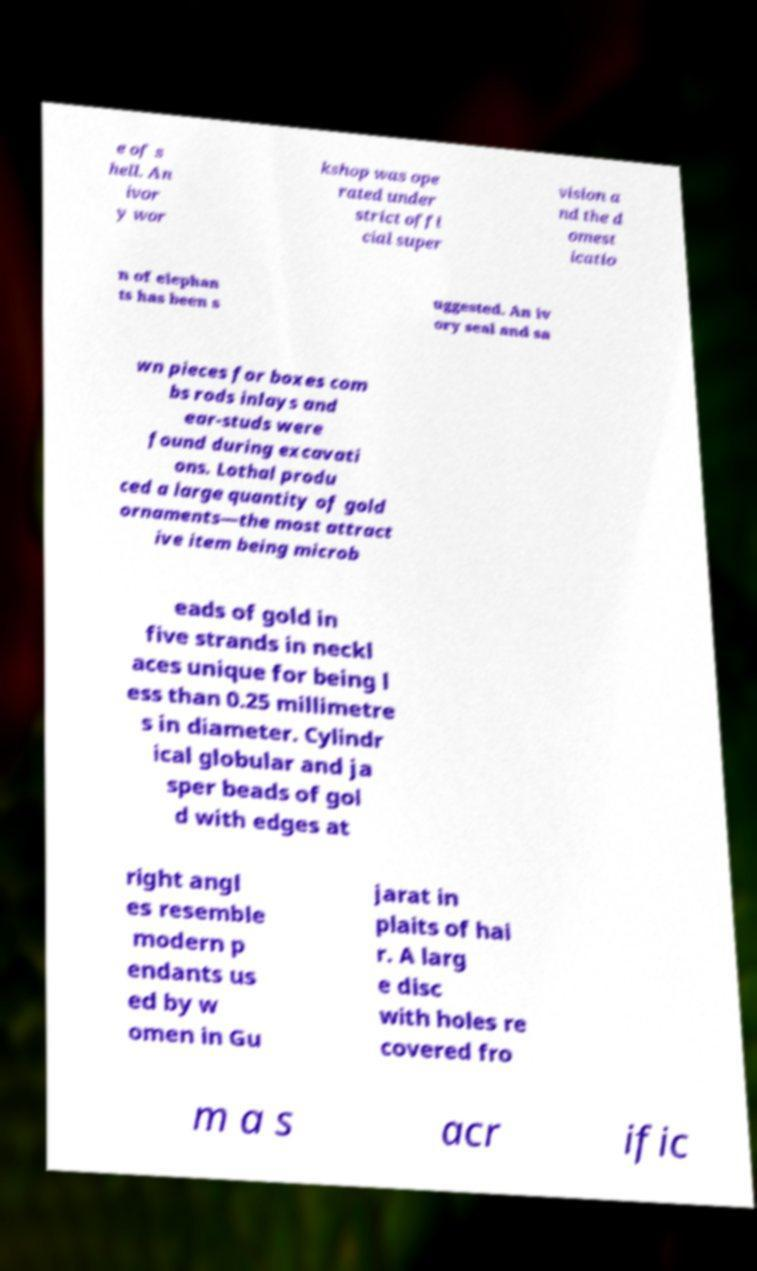Can you read and provide the text displayed in the image?This photo seems to have some interesting text. Can you extract and type it out for me? e of s hell. An ivor y wor kshop was ope rated under strict offi cial super vision a nd the d omest icatio n of elephan ts has been s uggested. An iv ory seal and sa wn pieces for boxes com bs rods inlays and ear-studs were found during excavati ons. Lothal produ ced a large quantity of gold ornaments—the most attract ive item being microb eads of gold in five strands in neckl aces unique for being l ess than 0.25 millimetre s in diameter. Cylindr ical globular and ja sper beads of gol d with edges at right angl es resemble modern p endants us ed by w omen in Gu jarat in plaits of hai r. A larg e disc with holes re covered fro m a s acr ific 